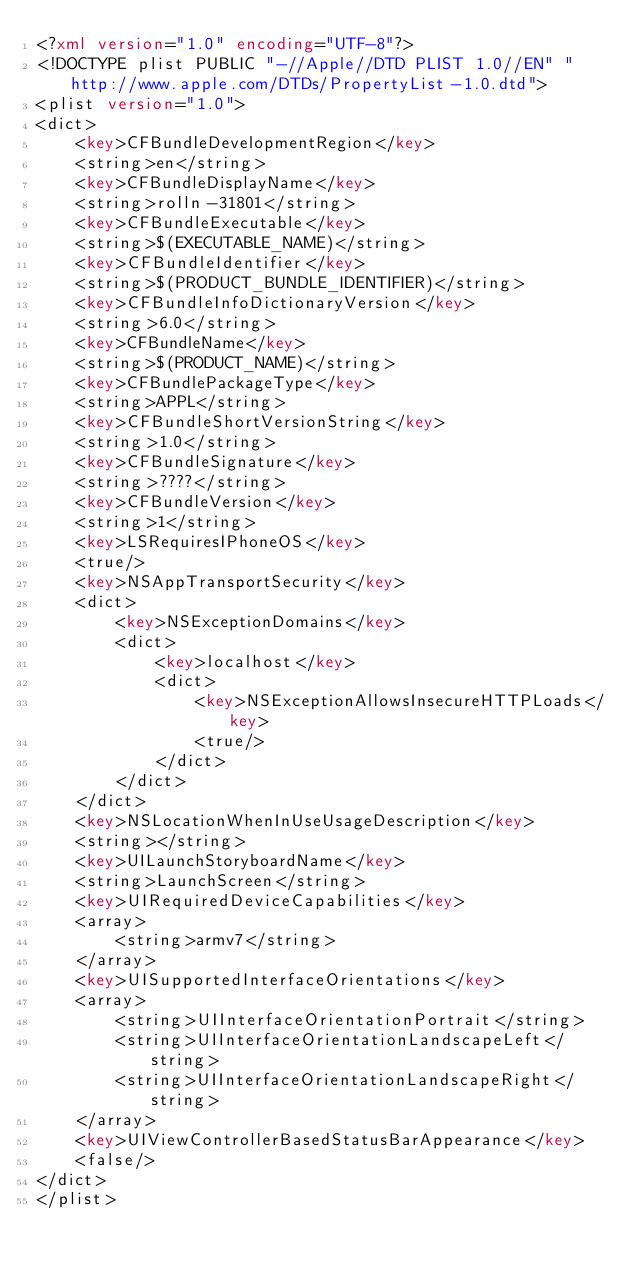Convert code to text. <code><loc_0><loc_0><loc_500><loc_500><_XML_><?xml version="1.0" encoding="UTF-8"?>
<!DOCTYPE plist PUBLIC "-//Apple//DTD PLIST 1.0//EN" "http://www.apple.com/DTDs/PropertyList-1.0.dtd">
<plist version="1.0">
<dict>
	<key>CFBundleDevelopmentRegion</key>
	<string>en</string>
	<key>CFBundleDisplayName</key>
	<string>rolln-31801</string>
	<key>CFBundleExecutable</key>
	<string>$(EXECUTABLE_NAME)</string>
	<key>CFBundleIdentifier</key>
	<string>$(PRODUCT_BUNDLE_IDENTIFIER)</string>
	<key>CFBundleInfoDictionaryVersion</key>
	<string>6.0</string>
	<key>CFBundleName</key>
	<string>$(PRODUCT_NAME)</string>
	<key>CFBundlePackageType</key>
	<string>APPL</string>
	<key>CFBundleShortVersionString</key>
	<string>1.0</string>
	<key>CFBundleSignature</key>
	<string>????</string>
	<key>CFBundleVersion</key>
	<string>1</string>
	<key>LSRequiresIPhoneOS</key>
	<true/>
	<key>NSAppTransportSecurity</key>
	<dict>
		<key>NSExceptionDomains</key>
		<dict>
			<key>localhost</key>
			<dict>
				<key>NSExceptionAllowsInsecureHTTPLoads</key>
				<true/>
			</dict>
		</dict>
	</dict>
	<key>NSLocationWhenInUseUsageDescription</key>
	<string></string>
	<key>UILaunchStoryboardName</key>
	<string>LaunchScreen</string>
	<key>UIRequiredDeviceCapabilities</key>
	<array>
		<string>armv7</string>
	</array>
	<key>UISupportedInterfaceOrientations</key>
	<array>
		<string>UIInterfaceOrientationPortrait</string>
		<string>UIInterfaceOrientationLandscapeLeft</string>
		<string>UIInterfaceOrientationLandscapeRight</string>
	</array>
	<key>UIViewControllerBasedStatusBarAppearance</key>
	<false/>
</dict>
</plist>
</code> 